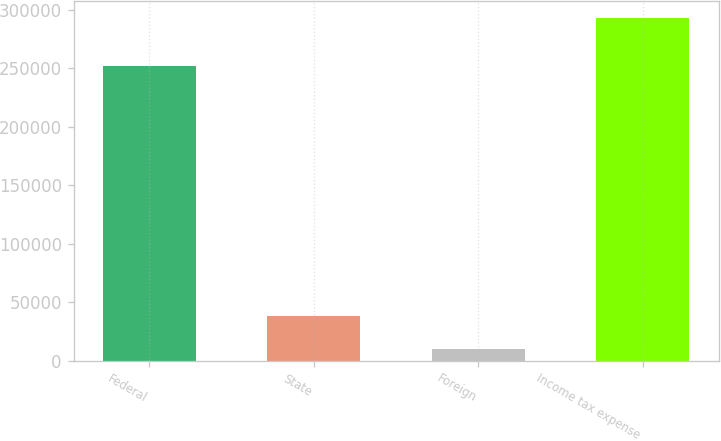<chart> <loc_0><loc_0><loc_500><loc_500><bar_chart><fcel>Federal<fcel>State<fcel>Foreign<fcel>Income tax expense<nl><fcel>252446<fcel>38161<fcel>9814<fcel>293284<nl></chart> 